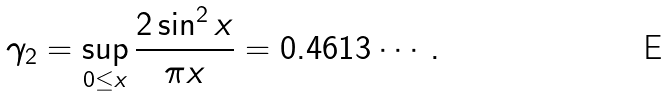<formula> <loc_0><loc_0><loc_500><loc_500>\gamma _ { 2 } = \sup _ { 0 \leq x } \frac { 2 \sin ^ { 2 } x } { \pi x } = 0 . 4 6 1 3 \cdots .</formula> 